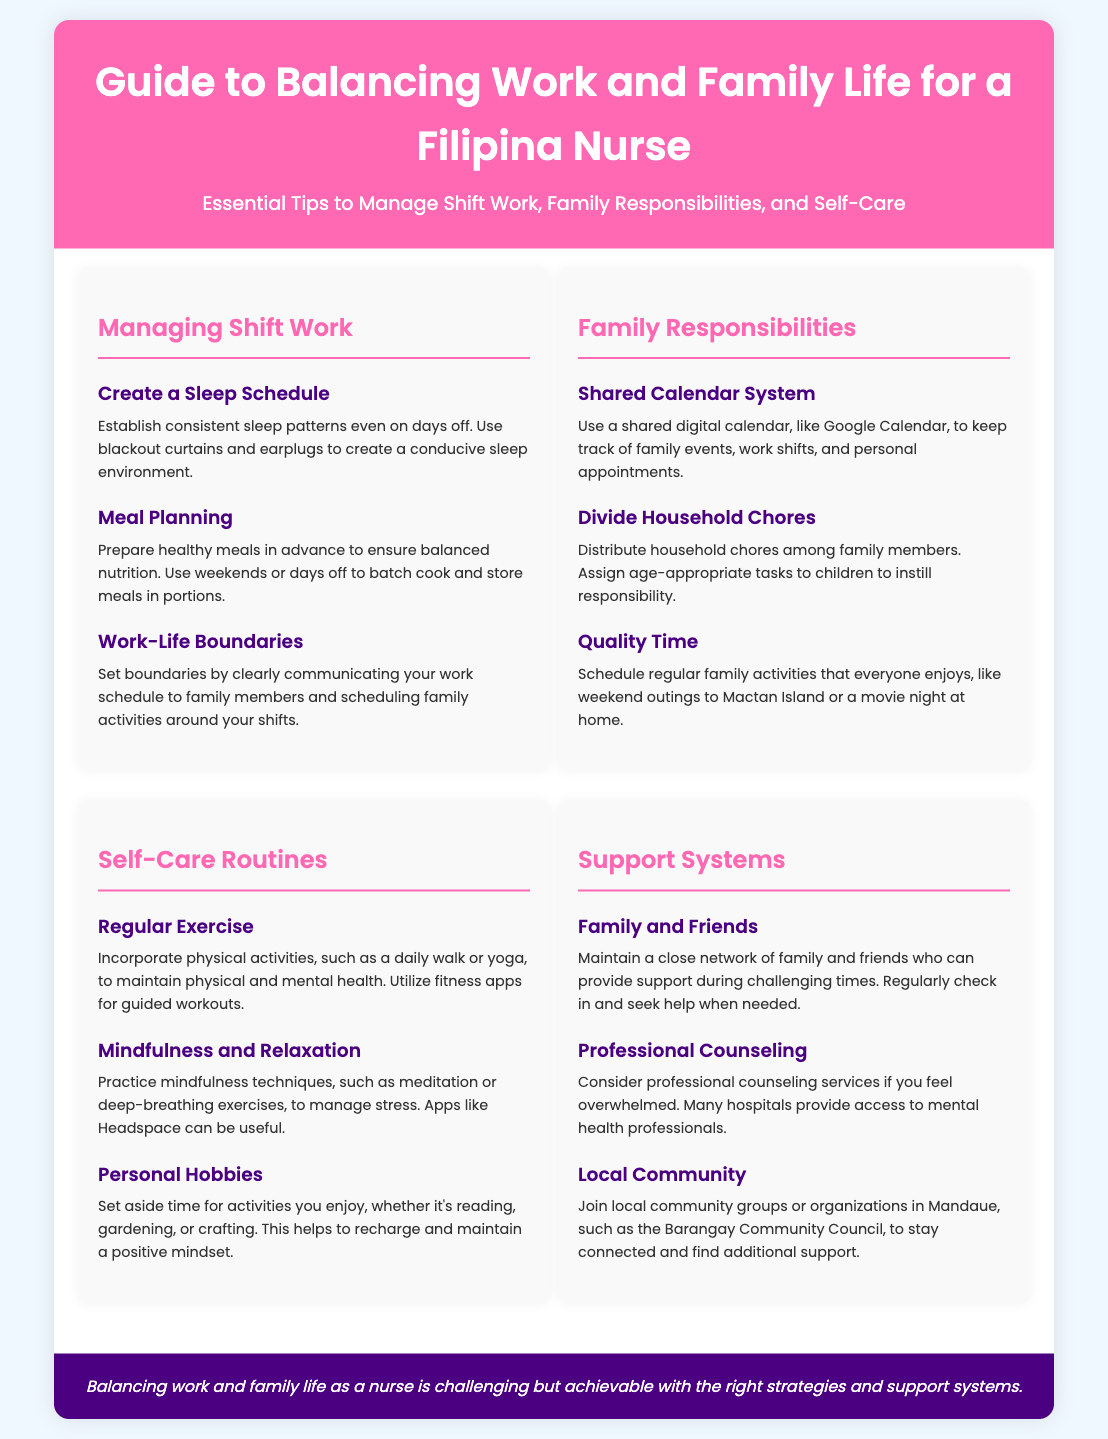what is the title of the document? The title of the document is found in the header section, which states the purpose of the infographic.
Answer: Guide to Balancing Work and Family Life for a Filipina Nurse how many sections are in the document? The document contains four main sections that categorize the tips provided.
Answer: Four what is one tip for managing shift work? A specific tip listed under the "Managing Shift Work" section is highlighted to aid nurses in their work-life balance.
Answer: Create a Sleep Schedule what shared system is suggested for family responsibilities? The document recommends a specific tool that can aid in organizing family events and responsibilities effectively.
Answer: Shared Calendar System which mental health support option is mentioned? The document discusses a specific form of support that can be sought if one feels overwhelmed, related to mental wellbeing.
Answer: Professional Counseling what is one self-care routine mentioned? An example provided in the self-care section to maintain health can be identified that encourages physical activity and mental wellness.
Answer: Regular Exercise how can family chores be divided? The document suggests a method for distributing responsibilities at home, considering family member capabilities.
Answer: Divide Household Chores what is a recommended activity for quality family time? A suggestion in the family responsibilities section emphasizes a certain gathering that can enhance family bonding.
Answer: Weekend outings to Mactan Island which local community group is mentioned for support? The document highlights a community organization that individuals can join in Mandaue for additional support and connection.
Answer: Barangay Community Council 